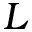<formula> <loc_0><loc_0><loc_500><loc_500>L</formula> 